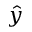Convert formula to latex. <formula><loc_0><loc_0><loc_500><loc_500>\hat { y }</formula> 